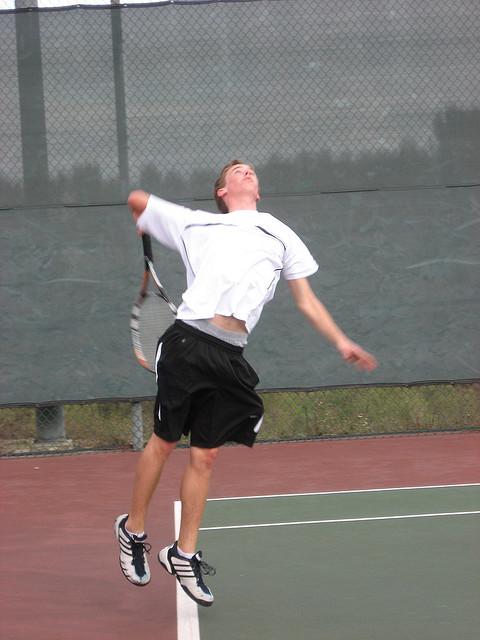What color is the man's t-shirt?
Quick response, please. White. What brand is the racquet?
Short answer required. Wilson. Has the man in this picture hit the tennis ball yet?
Give a very brief answer. No. Is this a man?
Be succinct. Yes. 